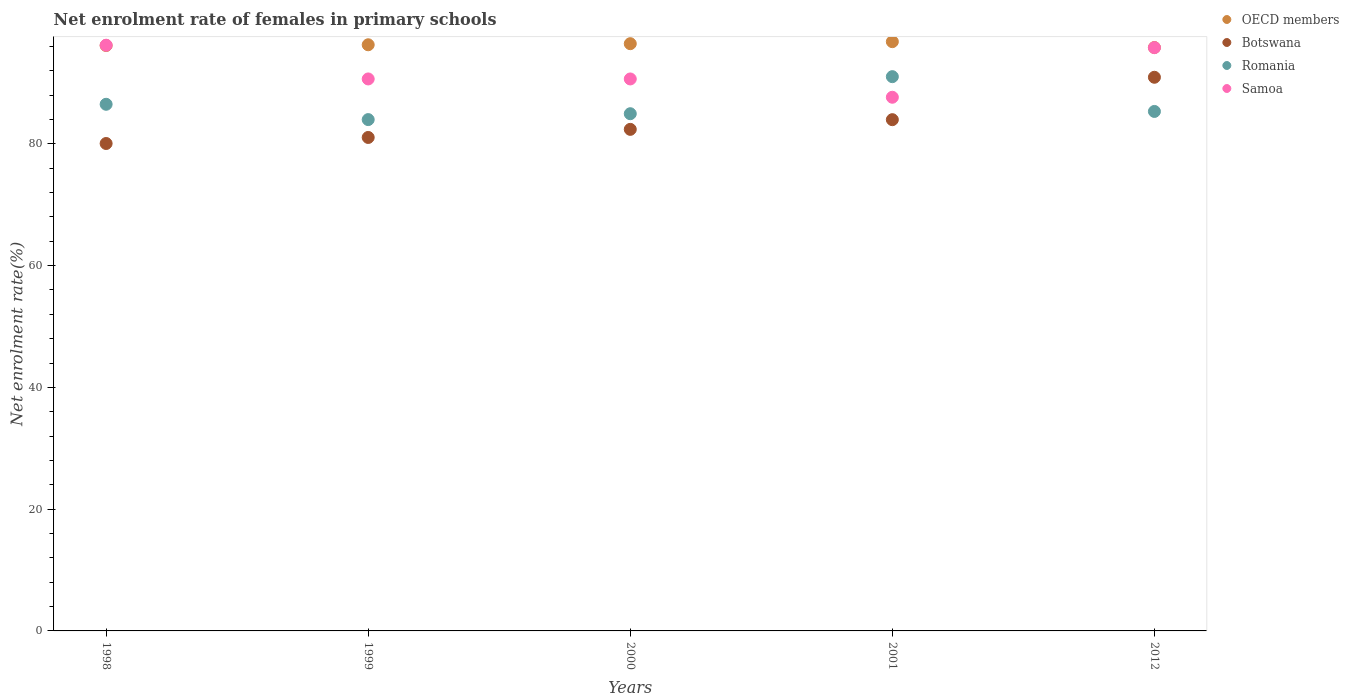How many different coloured dotlines are there?
Your answer should be very brief. 4. What is the net enrolment rate of females in primary schools in Romania in 1999?
Provide a short and direct response. 83.98. Across all years, what is the maximum net enrolment rate of females in primary schools in Romania?
Make the answer very short. 91.03. Across all years, what is the minimum net enrolment rate of females in primary schools in OECD members?
Give a very brief answer. 95.82. In which year was the net enrolment rate of females in primary schools in Samoa maximum?
Provide a short and direct response. 1998. In which year was the net enrolment rate of females in primary schools in Romania minimum?
Give a very brief answer. 1999. What is the total net enrolment rate of females in primary schools in Romania in the graph?
Offer a very short reply. 431.77. What is the difference between the net enrolment rate of females in primary schools in OECD members in 1998 and that in 2001?
Offer a terse response. -0.63. What is the difference between the net enrolment rate of females in primary schools in OECD members in 2000 and the net enrolment rate of females in primary schools in Romania in 2001?
Your answer should be compact. 5.42. What is the average net enrolment rate of females in primary schools in Samoa per year?
Give a very brief answer. 92.19. In the year 2001, what is the difference between the net enrolment rate of females in primary schools in Samoa and net enrolment rate of females in primary schools in OECD members?
Your answer should be compact. -9.13. What is the ratio of the net enrolment rate of females in primary schools in Romania in 1998 to that in 2000?
Provide a succinct answer. 1.02. Is the difference between the net enrolment rate of females in primary schools in Samoa in 2000 and 2012 greater than the difference between the net enrolment rate of females in primary schools in OECD members in 2000 and 2012?
Provide a succinct answer. No. What is the difference between the highest and the second highest net enrolment rate of females in primary schools in Botswana?
Offer a terse response. 6.96. What is the difference between the highest and the lowest net enrolment rate of females in primary schools in Samoa?
Your response must be concise. 8.55. In how many years, is the net enrolment rate of females in primary schools in Samoa greater than the average net enrolment rate of females in primary schools in Samoa taken over all years?
Provide a succinct answer. 2. Is it the case that in every year, the sum of the net enrolment rate of females in primary schools in Samoa and net enrolment rate of females in primary schools in Botswana  is greater than the sum of net enrolment rate of females in primary schools in OECD members and net enrolment rate of females in primary schools in Romania?
Offer a very short reply. No. Is the net enrolment rate of females in primary schools in OECD members strictly greater than the net enrolment rate of females in primary schools in Botswana over the years?
Ensure brevity in your answer.  Yes. Is the net enrolment rate of females in primary schools in Botswana strictly less than the net enrolment rate of females in primary schools in OECD members over the years?
Offer a very short reply. Yes. How many dotlines are there?
Your answer should be very brief. 4. How many years are there in the graph?
Your answer should be compact. 5. Are the values on the major ticks of Y-axis written in scientific E-notation?
Your answer should be very brief. No. Does the graph contain grids?
Provide a succinct answer. No. Where does the legend appear in the graph?
Keep it short and to the point. Top right. How are the legend labels stacked?
Make the answer very short. Vertical. What is the title of the graph?
Provide a succinct answer. Net enrolment rate of females in primary schools. Does "Greece" appear as one of the legend labels in the graph?
Your answer should be very brief. No. What is the label or title of the X-axis?
Keep it short and to the point. Years. What is the label or title of the Y-axis?
Your answer should be very brief. Net enrolment rate(%). What is the Net enrolment rate(%) in OECD members in 1998?
Your answer should be compact. 96.15. What is the Net enrolment rate(%) of Botswana in 1998?
Provide a succinct answer. 80.05. What is the Net enrolment rate(%) in Romania in 1998?
Your response must be concise. 86.49. What is the Net enrolment rate(%) of Samoa in 1998?
Provide a succinct answer. 96.2. What is the Net enrolment rate(%) in OECD members in 1999?
Make the answer very short. 96.27. What is the Net enrolment rate(%) of Botswana in 1999?
Offer a very short reply. 81.05. What is the Net enrolment rate(%) of Romania in 1999?
Ensure brevity in your answer.  83.98. What is the Net enrolment rate(%) in Samoa in 1999?
Offer a very short reply. 90.66. What is the Net enrolment rate(%) of OECD members in 2000?
Your answer should be very brief. 96.45. What is the Net enrolment rate(%) of Botswana in 2000?
Keep it short and to the point. 82.38. What is the Net enrolment rate(%) in Romania in 2000?
Your answer should be very brief. 84.94. What is the Net enrolment rate(%) of Samoa in 2000?
Your answer should be compact. 90.65. What is the Net enrolment rate(%) in OECD members in 2001?
Ensure brevity in your answer.  96.78. What is the Net enrolment rate(%) of Botswana in 2001?
Give a very brief answer. 83.97. What is the Net enrolment rate(%) of Romania in 2001?
Your answer should be very brief. 91.03. What is the Net enrolment rate(%) in Samoa in 2001?
Provide a short and direct response. 87.65. What is the Net enrolment rate(%) of OECD members in 2012?
Offer a terse response. 95.82. What is the Net enrolment rate(%) of Botswana in 2012?
Your response must be concise. 90.93. What is the Net enrolment rate(%) of Romania in 2012?
Offer a terse response. 85.32. What is the Net enrolment rate(%) of Samoa in 2012?
Offer a terse response. 95.79. Across all years, what is the maximum Net enrolment rate(%) of OECD members?
Give a very brief answer. 96.78. Across all years, what is the maximum Net enrolment rate(%) of Botswana?
Make the answer very short. 90.93. Across all years, what is the maximum Net enrolment rate(%) in Romania?
Provide a short and direct response. 91.03. Across all years, what is the maximum Net enrolment rate(%) in Samoa?
Your response must be concise. 96.2. Across all years, what is the minimum Net enrolment rate(%) in OECD members?
Provide a short and direct response. 95.82. Across all years, what is the minimum Net enrolment rate(%) of Botswana?
Make the answer very short. 80.05. Across all years, what is the minimum Net enrolment rate(%) in Romania?
Offer a terse response. 83.98. Across all years, what is the minimum Net enrolment rate(%) in Samoa?
Ensure brevity in your answer.  87.65. What is the total Net enrolment rate(%) of OECD members in the graph?
Give a very brief answer. 481.46. What is the total Net enrolment rate(%) of Botswana in the graph?
Your answer should be compact. 418.37. What is the total Net enrolment rate(%) in Romania in the graph?
Your response must be concise. 431.77. What is the total Net enrolment rate(%) of Samoa in the graph?
Give a very brief answer. 460.95. What is the difference between the Net enrolment rate(%) in OECD members in 1998 and that in 1999?
Give a very brief answer. -0.12. What is the difference between the Net enrolment rate(%) in Botswana in 1998 and that in 1999?
Provide a short and direct response. -0.99. What is the difference between the Net enrolment rate(%) of Romania in 1998 and that in 1999?
Keep it short and to the point. 2.51. What is the difference between the Net enrolment rate(%) of Samoa in 1998 and that in 1999?
Provide a short and direct response. 5.54. What is the difference between the Net enrolment rate(%) in OECD members in 1998 and that in 2000?
Offer a terse response. -0.3. What is the difference between the Net enrolment rate(%) of Botswana in 1998 and that in 2000?
Give a very brief answer. -2.32. What is the difference between the Net enrolment rate(%) of Romania in 1998 and that in 2000?
Your answer should be very brief. 1.55. What is the difference between the Net enrolment rate(%) in Samoa in 1998 and that in 2000?
Ensure brevity in your answer.  5.54. What is the difference between the Net enrolment rate(%) of OECD members in 1998 and that in 2001?
Provide a short and direct response. -0.63. What is the difference between the Net enrolment rate(%) in Botswana in 1998 and that in 2001?
Provide a short and direct response. -3.91. What is the difference between the Net enrolment rate(%) in Romania in 1998 and that in 2001?
Give a very brief answer. -4.54. What is the difference between the Net enrolment rate(%) in Samoa in 1998 and that in 2001?
Make the answer very short. 8.55. What is the difference between the Net enrolment rate(%) of OECD members in 1998 and that in 2012?
Offer a terse response. 0.33. What is the difference between the Net enrolment rate(%) in Botswana in 1998 and that in 2012?
Provide a succinct answer. -10.88. What is the difference between the Net enrolment rate(%) in Romania in 1998 and that in 2012?
Keep it short and to the point. 1.18. What is the difference between the Net enrolment rate(%) in Samoa in 1998 and that in 2012?
Provide a short and direct response. 0.4. What is the difference between the Net enrolment rate(%) in OECD members in 1999 and that in 2000?
Ensure brevity in your answer.  -0.18. What is the difference between the Net enrolment rate(%) in Botswana in 1999 and that in 2000?
Give a very brief answer. -1.33. What is the difference between the Net enrolment rate(%) in Romania in 1999 and that in 2000?
Offer a terse response. -0.97. What is the difference between the Net enrolment rate(%) of Samoa in 1999 and that in 2000?
Your answer should be compact. 0. What is the difference between the Net enrolment rate(%) of OECD members in 1999 and that in 2001?
Offer a terse response. -0.51. What is the difference between the Net enrolment rate(%) in Botswana in 1999 and that in 2001?
Offer a very short reply. -2.92. What is the difference between the Net enrolment rate(%) of Romania in 1999 and that in 2001?
Provide a short and direct response. -7.05. What is the difference between the Net enrolment rate(%) of Samoa in 1999 and that in 2001?
Provide a short and direct response. 3.01. What is the difference between the Net enrolment rate(%) of OECD members in 1999 and that in 2012?
Provide a succinct answer. 0.45. What is the difference between the Net enrolment rate(%) in Botswana in 1999 and that in 2012?
Ensure brevity in your answer.  -9.89. What is the difference between the Net enrolment rate(%) of Romania in 1999 and that in 2012?
Offer a very short reply. -1.34. What is the difference between the Net enrolment rate(%) in Samoa in 1999 and that in 2012?
Provide a short and direct response. -5.14. What is the difference between the Net enrolment rate(%) of OECD members in 2000 and that in 2001?
Make the answer very short. -0.33. What is the difference between the Net enrolment rate(%) of Botswana in 2000 and that in 2001?
Ensure brevity in your answer.  -1.59. What is the difference between the Net enrolment rate(%) in Romania in 2000 and that in 2001?
Offer a very short reply. -6.09. What is the difference between the Net enrolment rate(%) of Samoa in 2000 and that in 2001?
Your answer should be compact. 3. What is the difference between the Net enrolment rate(%) in OECD members in 2000 and that in 2012?
Your response must be concise. 0.63. What is the difference between the Net enrolment rate(%) in Botswana in 2000 and that in 2012?
Provide a succinct answer. -8.56. What is the difference between the Net enrolment rate(%) in Romania in 2000 and that in 2012?
Provide a short and direct response. -0.37. What is the difference between the Net enrolment rate(%) of Samoa in 2000 and that in 2012?
Give a very brief answer. -5.14. What is the difference between the Net enrolment rate(%) of OECD members in 2001 and that in 2012?
Your answer should be compact. 0.96. What is the difference between the Net enrolment rate(%) of Botswana in 2001 and that in 2012?
Offer a terse response. -6.96. What is the difference between the Net enrolment rate(%) of Romania in 2001 and that in 2012?
Your response must be concise. 5.71. What is the difference between the Net enrolment rate(%) in Samoa in 2001 and that in 2012?
Make the answer very short. -8.14. What is the difference between the Net enrolment rate(%) in OECD members in 1998 and the Net enrolment rate(%) in Botswana in 1999?
Your answer should be compact. 15.1. What is the difference between the Net enrolment rate(%) in OECD members in 1998 and the Net enrolment rate(%) in Romania in 1999?
Your response must be concise. 12.17. What is the difference between the Net enrolment rate(%) of OECD members in 1998 and the Net enrolment rate(%) of Samoa in 1999?
Ensure brevity in your answer.  5.49. What is the difference between the Net enrolment rate(%) of Botswana in 1998 and the Net enrolment rate(%) of Romania in 1999?
Ensure brevity in your answer.  -3.93. What is the difference between the Net enrolment rate(%) in Botswana in 1998 and the Net enrolment rate(%) in Samoa in 1999?
Offer a terse response. -10.6. What is the difference between the Net enrolment rate(%) of Romania in 1998 and the Net enrolment rate(%) of Samoa in 1999?
Your answer should be compact. -4.16. What is the difference between the Net enrolment rate(%) in OECD members in 1998 and the Net enrolment rate(%) in Botswana in 2000?
Offer a very short reply. 13.77. What is the difference between the Net enrolment rate(%) in OECD members in 1998 and the Net enrolment rate(%) in Romania in 2000?
Give a very brief answer. 11.2. What is the difference between the Net enrolment rate(%) of OECD members in 1998 and the Net enrolment rate(%) of Samoa in 2000?
Make the answer very short. 5.49. What is the difference between the Net enrolment rate(%) in Botswana in 1998 and the Net enrolment rate(%) in Romania in 2000?
Provide a short and direct response. -4.89. What is the difference between the Net enrolment rate(%) of Botswana in 1998 and the Net enrolment rate(%) of Samoa in 2000?
Keep it short and to the point. -10.6. What is the difference between the Net enrolment rate(%) in Romania in 1998 and the Net enrolment rate(%) in Samoa in 2000?
Make the answer very short. -4.16. What is the difference between the Net enrolment rate(%) of OECD members in 1998 and the Net enrolment rate(%) of Botswana in 2001?
Provide a succinct answer. 12.18. What is the difference between the Net enrolment rate(%) of OECD members in 1998 and the Net enrolment rate(%) of Romania in 2001?
Offer a terse response. 5.11. What is the difference between the Net enrolment rate(%) of OECD members in 1998 and the Net enrolment rate(%) of Samoa in 2001?
Your response must be concise. 8.5. What is the difference between the Net enrolment rate(%) of Botswana in 1998 and the Net enrolment rate(%) of Romania in 2001?
Offer a terse response. -10.98. What is the difference between the Net enrolment rate(%) in Botswana in 1998 and the Net enrolment rate(%) in Samoa in 2001?
Give a very brief answer. -7.6. What is the difference between the Net enrolment rate(%) of Romania in 1998 and the Net enrolment rate(%) of Samoa in 2001?
Offer a terse response. -1.15. What is the difference between the Net enrolment rate(%) of OECD members in 1998 and the Net enrolment rate(%) of Botswana in 2012?
Make the answer very short. 5.21. What is the difference between the Net enrolment rate(%) in OECD members in 1998 and the Net enrolment rate(%) in Romania in 2012?
Keep it short and to the point. 10.83. What is the difference between the Net enrolment rate(%) in OECD members in 1998 and the Net enrolment rate(%) in Samoa in 2012?
Your response must be concise. 0.35. What is the difference between the Net enrolment rate(%) of Botswana in 1998 and the Net enrolment rate(%) of Romania in 2012?
Your response must be concise. -5.27. What is the difference between the Net enrolment rate(%) in Botswana in 1998 and the Net enrolment rate(%) in Samoa in 2012?
Your response must be concise. -15.74. What is the difference between the Net enrolment rate(%) in Romania in 1998 and the Net enrolment rate(%) in Samoa in 2012?
Make the answer very short. -9.3. What is the difference between the Net enrolment rate(%) in OECD members in 1999 and the Net enrolment rate(%) in Botswana in 2000?
Offer a very short reply. 13.89. What is the difference between the Net enrolment rate(%) of OECD members in 1999 and the Net enrolment rate(%) of Romania in 2000?
Ensure brevity in your answer.  11.32. What is the difference between the Net enrolment rate(%) of OECD members in 1999 and the Net enrolment rate(%) of Samoa in 2000?
Provide a succinct answer. 5.61. What is the difference between the Net enrolment rate(%) of Botswana in 1999 and the Net enrolment rate(%) of Romania in 2000?
Your answer should be very brief. -3.9. What is the difference between the Net enrolment rate(%) of Botswana in 1999 and the Net enrolment rate(%) of Samoa in 2000?
Provide a short and direct response. -9.61. What is the difference between the Net enrolment rate(%) of Romania in 1999 and the Net enrolment rate(%) of Samoa in 2000?
Offer a very short reply. -6.67. What is the difference between the Net enrolment rate(%) of OECD members in 1999 and the Net enrolment rate(%) of Botswana in 2001?
Offer a very short reply. 12.3. What is the difference between the Net enrolment rate(%) in OECD members in 1999 and the Net enrolment rate(%) in Romania in 2001?
Keep it short and to the point. 5.24. What is the difference between the Net enrolment rate(%) in OECD members in 1999 and the Net enrolment rate(%) in Samoa in 2001?
Your answer should be very brief. 8.62. What is the difference between the Net enrolment rate(%) in Botswana in 1999 and the Net enrolment rate(%) in Romania in 2001?
Give a very brief answer. -9.99. What is the difference between the Net enrolment rate(%) in Botswana in 1999 and the Net enrolment rate(%) in Samoa in 2001?
Offer a terse response. -6.6. What is the difference between the Net enrolment rate(%) in Romania in 1999 and the Net enrolment rate(%) in Samoa in 2001?
Your answer should be compact. -3.67. What is the difference between the Net enrolment rate(%) of OECD members in 1999 and the Net enrolment rate(%) of Botswana in 2012?
Your answer should be compact. 5.34. What is the difference between the Net enrolment rate(%) of OECD members in 1999 and the Net enrolment rate(%) of Romania in 2012?
Provide a short and direct response. 10.95. What is the difference between the Net enrolment rate(%) in OECD members in 1999 and the Net enrolment rate(%) in Samoa in 2012?
Ensure brevity in your answer.  0.47. What is the difference between the Net enrolment rate(%) of Botswana in 1999 and the Net enrolment rate(%) of Romania in 2012?
Ensure brevity in your answer.  -4.27. What is the difference between the Net enrolment rate(%) of Botswana in 1999 and the Net enrolment rate(%) of Samoa in 2012?
Provide a succinct answer. -14.75. What is the difference between the Net enrolment rate(%) in Romania in 1999 and the Net enrolment rate(%) in Samoa in 2012?
Give a very brief answer. -11.81. What is the difference between the Net enrolment rate(%) in OECD members in 2000 and the Net enrolment rate(%) in Botswana in 2001?
Keep it short and to the point. 12.48. What is the difference between the Net enrolment rate(%) of OECD members in 2000 and the Net enrolment rate(%) of Romania in 2001?
Ensure brevity in your answer.  5.42. What is the difference between the Net enrolment rate(%) in OECD members in 2000 and the Net enrolment rate(%) in Samoa in 2001?
Provide a short and direct response. 8.8. What is the difference between the Net enrolment rate(%) of Botswana in 2000 and the Net enrolment rate(%) of Romania in 2001?
Give a very brief answer. -8.66. What is the difference between the Net enrolment rate(%) of Botswana in 2000 and the Net enrolment rate(%) of Samoa in 2001?
Provide a short and direct response. -5.27. What is the difference between the Net enrolment rate(%) in Romania in 2000 and the Net enrolment rate(%) in Samoa in 2001?
Provide a short and direct response. -2.7. What is the difference between the Net enrolment rate(%) of OECD members in 2000 and the Net enrolment rate(%) of Botswana in 2012?
Your answer should be very brief. 5.52. What is the difference between the Net enrolment rate(%) in OECD members in 2000 and the Net enrolment rate(%) in Romania in 2012?
Your answer should be very brief. 11.13. What is the difference between the Net enrolment rate(%) in OECD members in 2000 and the Net enrolment rate(%) in Samoa in 2012?
Keep it short and to the point. 0.65. What is the difference between the Net enrolment rate(%) in Botswana in 2000 and the Net enrolment rate(%) in Romania in 2012?
Offer a very short reply. -2.94. What is the difference between the Net enrolment rate(%) in Botswana in 2000 and the Net enrolment rate(%) in Samoa in 2012?
Offer a very short reply. -13.42. What is the difference between the Net enrolment rate(%) of Romania in 2000 and the Net enrolment rate(%) of Samoa in 2012?
Your answer should be compact. -10.85. What is the difference between the Net enrolment rate(%) in OECD members in 2001 and the Net enrolment rate(%) in Botswana in 2012?
Provide a succinct answer. 5.85. What is the difference between the Net enrolment rate(%) of OECD members in 2001 and the Net enrolment rate(%) of Romania in 2012?
Your answer should be compact. 11.46. What is the difference between the Net enrolment rate(%) in OECD members in 2001 and the Net enrolment rate(%) in Samoa in 2012?
Offer a very short reply. 0.98. What is the difference between the Net enrolment rate(%) of Botswana in 2001 and the Net enrolment rate(%) of Romania in 2012?
Provide a short and direct response. -1.35. What is the difference between the Net enrolment rate(%) in Botswana in 2001 and the Net enrolment rate(%) in Samoa in 2012?
Keep it short and to the point. -11.83. What is the difference between the Net enrolment rate(%) of Romania in 2001 and the Net enrolment rate(%) of Samoa in 2012?
Provide a succinct answer. -4.76. What is the average Net enrolment rate(%) in OECD members per year?
Offer a terse response. 96.29. What is the average Net enrolment rate(%) in Botswana per year?
Keep it short and to the point. 83.67. What is the average Net enrolment rate(%) of Romania per year?
Ensure brevity in your answer.  86.35. What is the average Net enrolment rate(%) in Samoa per year?
Provide a succinct answer. 92.19. In the year 1998, what is the difference between the Net enrolment rate(%) of OECD members and Net enrolment rate(%) of Botswana?
Offer a very short reply. 16.09. In the year 1998, what is the difference between the Net enrolment rate(%) in OECD members and Net enrolment rate(%) in Romania?
Provide a short and direct response. 9.65. In the year 1998, what is the difference between the Net enrolment rate(%) of OECD members and Net enrolment rate(%) of Samoa?
Offer a very short reply. -0.05. In the year 1998, what is the difference between the Net enrolment rate(%) of Botswana and Net enrolment rate(%) of Romania?
Your response must be concise. -6.44. In the year 1998, what is the difference between the Net enrolment rate(%) in Botswana and Net enrolment rate(%) in Samoa?
Your answer should be very brief. -16.14. In the year 1998, what is the difference between the Net enrolment rate(%) of Romania and Net enrolment rate(%) of Samoa?
Offer a very short reply. -9.7. In the year 1999, what is the difference between the Net enrolment rate(%) of OECD members and Net enrolment rate(%) of Botswana?
Offer a very short reply. 15.22. In the year 1999, what is the difference between the Net enrolment rate(%) in OECD members and Net enrolment rate(%) in Romania?
Give a very brief answer. 12.29. In the year 1999, what is the difference between the Net enrolment rate(%) in OECD members and Net enrolment rate(%) in Samoa?
Your answer should be compact. 5.61. In the year 1999, what is the difference between the Net enrolment rate(%) of Botswana and Net enrolment rate(%) of Romania?
Offer a very short reply. -2.93. In the year 1999, what is the difference between the Net enrolment rate(%) in Botswana and Net enrolment rate(%) in Samoa?
Ensure brevity in your answer.  -9.61. In the year 1999, what is the difference between the Net enrolment rate(%) of Romania and Net enrolment rate(%) of Samoa?
Give a very brief answer. -6.68. In the year 2000, what is the difference between the Net enrolment rate(%) in OECD members and Net enrolment rate(%) in Botswana?
Make the answer very short. 14.07. In the year 2000, what is the difference between the Net enrolment rate(%) in OECD members and Net enrolment rate(%) in Romania?
Provide a succinct answer. 11.5. In the year 2000, what is the difference between the Net enrolment rate(%) of OECD members and Net enrolment rate(%) of Samoa?
Make the answer very short. 5.79. In the year 2000, what is the difference between the Net enrolment rate(%) in Botswana and Net enrolment rate(%) in Romania?
Keep it short and to the point. -2.57. In the year 2000, what is the difference between the Net enrolment rate(%) in Botswana and Net enrolment rate(%) in Samoa?
Your answer should be compact. -8.28. In the year 2000, what is the difference between the Net enrolment rate(%) in Romania and Net enrolment rate(%) in Samoa?
Offer a terse response. -5.71. In the year 2001, what is the difference between the Net enrolment rate(%) of OECD members and Net enrolment rate(%) of Botswana?
Offer a terse response. 12.81. In the year 2001, what is the difference between the Net enrolment rate(%) in OECD members and Net enrolment rate(%) in Romania?
Your answer should be very brief. 5.75. In the year 2001, what is the difference between the Net enrolment rate(%) in OECD members and Net enrolment rate(%) in Samoa?
Offer a terse response. 9.13. In the year 2001, what is the difference between the Net enrolment rate(%) in Botswana and Net enrolment rate(%) in Romania?
Make the answer very short. -7.06. In the year 2001, what is the difference between the Net enrolment rate(%) of Botswana and Net enrolment rate(%) of Samoa?
Ensure brevity in your answer.  -3.68. In the year 2001, what is the difference between the Net enrolment rate(%) in Romania and Net enrolment rate(%) in Samoa?
Ensure brevity in your answer.  3.38. In the year 2012, what is the difference between the Net enrolment rate(%) in OECD members and Net enrolment rate(%) in Botswana?
Your response must be concise. 4.89. In the year 2012, what is the difference between the Net enrolment rate(%) of OECD members and Net enrolment rate(%) of Romania?
Ensure brevity in your answer.  10.5. In the year 2012, what is the difference between the Net enrolment rate(%) of OECD members and Net enrolment rate(%) of Samoa?
Provide a short and direct response. 0.02. In the year 2012, what is the difference between the Net enrolment rate(%) of Botswana and Net enrolment rate(%) of Romania?
Provide a short and direct response. 5.61. In the year 2012, what is the difference between the Net enrolment rate(%) in Botswana and Net enrolment rate(%) in Samoa?
Provide a succinct answer. -4.86. In the year 2012, what is the difference between the Net enrolment rate(%) in Romania and Net enrolment rate(%) in Samoa?
Keep it short and to the point. -10.47. What is the ratio of the Net enrolment rate(%) of OECD members in 1998 to that in 1999?
Provide a succinct answer. 1. What is the ratio of the Net enrolment rate(%) of Romania in 1998 to that in 1999?
Offer a very short reply. 1.03. What is the ratio of the Net enrolment rate(%) in Samoa in 1998 to that in 1999?
Your response must be concise. 1.06. What is the ratio of the Net enrolment rate(%) of OECD members in 1998 to that in 2000?
Give a very brief answer. 1. What is the ratio of the Net enrolment rate(%) in Botswana in 1998 to that in 2000?
Your answer should be compact. 0.97. What is the ratio of the Net enrolment rate(%) of Romania in 1998 to that in 2000?
Keep it short and to the point. 1.02. What is the ratio of the Net enrolment rate(%) in Samoa in 1998 to that in 2000?
Provide a short and direct response. 1.06. What is the ratio of the Net enrolment rate(%) in Botswana in 1998 to that in 2001?
Your answer should be compact. 0.95. What is the ratio of the Net enrolment rate(%) of Romania in 1998 to that in 2001?
Your answer should be compact. 0.95. What is the ratio of the Net enrolment rate(%) of Samoa in 1998 to that in 2001?
Offer a very short reply. 1.1. What is the ratio of the Net enrolment rate(%) in OECD members in 1998 to that in 2012?
Keep it short and to the point. 1. What is the ratio of the Net enrolment rate(%) of Botswana in 1998 to that in 2012?
Your answer should be very brief. 0.88. What is the ratio of the Net enrolment rate(%) in Romania in 1998 to that in 2012?
Your answer should be compact. 1.01. What is the ratio of the Net enrolment rate(%) in OECD members in 1999 to that in 2000?
Provide a short and direct response. 1. What is the ratio of the Net enrolment rate(%) of Botswana in 1999 to that in 2000?
Ensure brevity in your answer.  0.98. What is the ratio of the Net enrolment rate(%) of Romania in 1999 to that in 2000?
Provide a succinct answer. 0.99. What is the ratio of the Net enrolment rate(%) of Samoa in 1999 to that in 2000?
Provide a short and direct response. 1. What is the ratio of the Net enrolment rate(%) in OECD members in 1999 to that in 2001?
Offer a very short reply. 0.99. What is the ratio of the Net enrolment rate(%) in Botswana in 1999 to that in 2001?
Offer a very short reply. 0.97. What is the ratio of the Net enrolment rate(%) in Romania in 1999 to that in 2001?
Give a very brief answer. 0.92. What is the ratio of the Net enrolment rate(%) of Samoa in 1999 to that in 2001?
Your response must be concise. 1.03. What is the ratio of the Net enrolment rate(%) of Botswana in 1999 to that in 2012?
Offer a very short reply. 0.89. What is the ratio of the Net enrolment rate(%) of Romania in 1999 to that in 2012?
Give a very brief answer. 0.98. What is the ratio of the Net enrolment rate(%) of Samoa in 1999 to that in 2012?
Provide a succinct answer. 0.95. What is the ratio of the Net enrolment rate(%) in Botswana in 2000 to that in 2001?
Ensure brevity in your answer.  0.98. What is the ratio of the Net enrolment rate(%) in Romania in 2000 to that in 2001?
Offer a very short reply. 0.93. What is the ratio of the Net enrolment rate(%) in Samoa in 2000 to that in 2001?
Your answer should be compact. 1.03. What is the ratio of the Net enrolment rate(%) in OECD members in 2000 to that in 2012?
Offer a very short reply. 1.01. What is the ratio of the Net enrolment rate(%) of Botswana in 2000 to that in 2012?
Provide a succinct answer. 0.91. What is the ratio of the Net enrolment rate(%) in Romania in 2000 to that in 2012?
Give a very brief answer. 1. What is the ratio of the Net enrolment rate(%) in Samoa in 2000 to that in 2012?
Your answer should be compact. 0.95. What is the ratio of the Net enrolment rate(%) in OECD members in 2001 to that in 2012?
Give a very brief answer. 1.01. What is the ratio of the Net enrolment rate(%) of Botswana in 2001 to that in 2012?
Provide a succinct answer. 0.92. What is the ratio of the Net enrolment rate(%) of Romania in 2001 to that in 2012?
Your answer should be compact. 1.07. What is the ratio of the Net enrolment rate(%) in Samoa in 2001 to that in 2012?
Your answer should be very brief. 0.92. What is the difference between the highest and the second highest Net enrolment rate(%) of OECD members?
Provide a succinct answer. 0.33. What is the difference between the highest and the second highest Net enrolment rate(%) in Botswana?
Offer a very short reply. 6.96. What is the difference between the highest and the second highest Net enrolment rate(%) of Romania?
Provide a short and direct response. 4.54. What is the difference between the highest and the second highest Net enrolment rate(%) of Samoa?
Offer a very short reply. 0.4. What is the difference between the highest and the lowest Net enrolment rate(%) in OECD members?
Your answer should be very brief. 0.96. What is the difference between the highest and the lowest Net enrolment rate(%) in Botswana?
Your answer should be compact. 10.88. What is the difference between the highest and the lowest Net enrolment rate(%) of Romania?
Provide a succinct answer. 7.05. What is the difference between the highest and the lowest Net enrolment rate(%) in Samoa?
Offer a terse response. 8.55. 